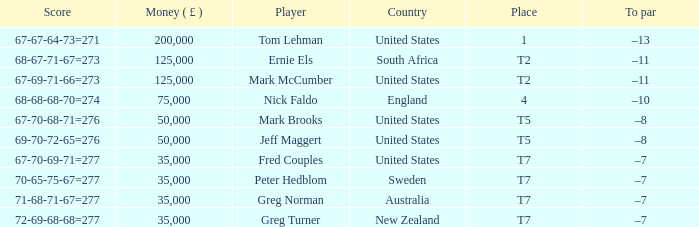When the money (£) is over 35,000 and the country is "united states," what is the score? 67-67-64-73=271, 67-69-71-66=273, 67-70-68-71=276, 69-70-72-65=276. 